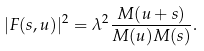<formula> <loc_0><loc_0><loc_500><loc_500>| F ( s , u ) | ^ { 2 } = \lambda ^ { 2 } \frac { M ( u + s ) } { M ( u ) M ( s ) } .</formula> 